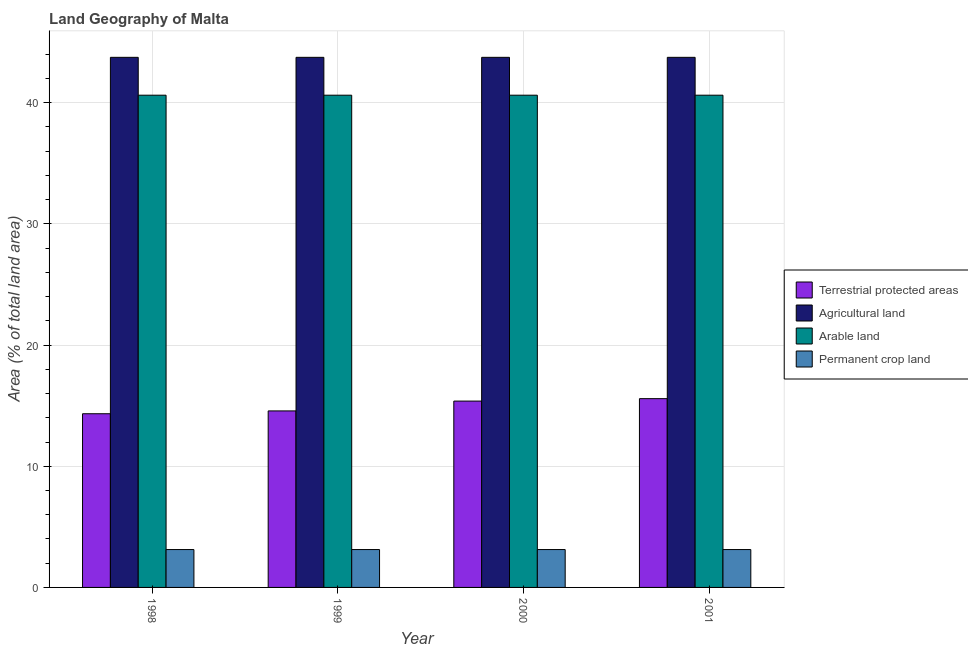How many different coloured bars are there?
Your response must be concise. 4. How many groups of bars are there?
Offer a very short reply. 4. In how many cases, is the number of bars for a given year not equal to the number of legend labels?
Offer a very short reply. 0. What is the percentage of land under terrestrial protection in 1999?
Make the answer very short. 14.57. Across all years, what is the maximum percentage of area under permanent crop land?
Your answer should be very brief. 3.12. Across all years, what is the minimum percentage of land under terrestrial protection?
Offer a terse response. 14.33. What is the total percentage of land under terrestrial protection in the graph?
Keep it short and to the point. 59.86. What is the difference between the percentage of area under permanent crop land in 2001 and the percentage of area under arable land in 2000?
Offer a terse response. 0. What is the average percentage of area under arable land per year?
Your answer should be very brief. 40.62. In the year 2001, what is the difference between the percentage of area under permanent crop land and percentage of land under terrestrial protection?
Ensure brevity in your answer.  0. In how many years, is the percentage of area under arable land greater than 18 %?
Offer a terse response. 4. What is the ratio of the percentage of area under agricultural land in 1998 to that in 1999?
Keep it short and to the point. 1. What does the 4th bar from the left in 2000 represents?
Offer a very short reply. Permanent crop land. What does the 3rd bar from the right in 1999 represents?
Give a very brief answer. Agricultural land. How many years are there in the graph?
Ensure brevity in your answer.  4. What is the difference between two consecutive major ticks on the Y-axis?
Ensure brevity in your answer.  10. Where does the legend appear in the graph?
Your answer should be compact. Center right. How many legend labels are there?
Offer a terse response. 4. What is the title of the graph?
Your answer should be compact. Land Geography of Malta. Does "France" appear as one of the legend labels in the graph?
Keep it short and to the point. No. What is the label or title of the Y-axis?
Offer a very short reply. Area (% of total land area). What is the Area (% of total land area) in Terrestrial protected areas in 1998?
Your answer should be very brief. 14.33. What is the Area (% of total land area) in Agricultural land in 1998?
Provide a succinct answer. 43.75. What is the Area (% of total land area) of Arable land in 1998?
Your answer should be compact. 40.62. What is the Area (% of total land area) of Permanent crop land in 1998?
Ensure brevity in your answer.  3.12. What is the Area (% of total land area) in Terrestrial protected areas in 1999?
Provide a succinct answer. 14.57. What is the Area (% of total land area) of Agricultural land in 1999?
Provide a succinct answer. 43.75. What is the Area (% of total land area) in Arable land in 1999?
Offer a terse response. 40.62. What is the Area (% of total land area) in Permanent crop land in 1999?
Offer a terse response. 3.12. What is the Area (% of total land area) in Terrestrial protected areas in 2000?
Offer a very short reply. 15.38. What is the Area (% of total land area) of Agricultural land in 2000?
Give a very brief answer. 43.75. What is the Area (% of total land area) in Arable land in 2000?
Offer a very short reply. 40.62. What is the Area (% of total land area) of Permanent crop land in 2000?
Make the answer very short. 3.12. What is the Area (% of total land area) in Terrestrial protected areas in 2001?
Offer a very short reply. 15.58. What is the Area (% of total land area) in Agricultural land in 2001?
Make the answer very short. 43.75. What is the Area (% of total land area) in Arable land in 2001?
Provide a succinct answer. 40.62. What is the Area (% of total land area) in Permanent crop land in 2001?
Keep it short and to the point. 3.12. Across all years, what is the maximum Area (% of total land area) of Terrestrial protected areas?
Your answer should be very brief. 15.58. Across all years, what is the maximum Area (% of total land area) in Agricultural land?
Give a very brief answer. 43.75. Across all years, what is the maximum Area (% of total land area) in Arable land?
Your answer should be very brief. 40.62. Across all years, what is the maximum Area (% of total land area) of Permanent crop land?
Keep it short and to the point. 3.12. Across all years, what is the minimum Area (% of total land area) in Terrestrial protected areas?
Make the answer very short. 14.33. Across all years, what is the minimum Area (% of total land area) of Agricultural land?
Provide a short and direct response. 43.75. Across all years, what is the minimum Area (% of total land area) of Arable land?
Offer a very short reply. 40.62. Across all years, what is the minimum Area (% of total land area) in Permanent crop land?
Your answer should be very brief. 3.12. What is the total Area (% of total land area) in Terrestrial protected areas in the graph?
Give a very brief answer. 59.86. What is the total Area (% of total land area) of Agricultural land in the graph?
Your answer should be compact. 175. What is the total Area (% of total land area) of Arable land in the graph?
Your response must be concise. 162.5. What is the difference between the Area (% of total land area) of Terrestrial protected areas in 1998 and that in 1999?
Your response must be concise. -0.23. What is the difference between the Area (% of total land area) in Permanent crop land in 1998 and that in 1999?
Give a very brief answer. 0. What is the difference between the Area (% of total land area) in Terrestrial protected areas in 1998 and that in 2000?
Your answer should be very brief. -1.04. What is the difference between the Area (% of total land area) in Agricultural land in 1998 and that in 2000?
Your answer should be compact. 0. What is the difference between the Area (% of total land area) of Arable land in 1998 and that in 2000?
Offer a very short reply. 0. What is the difference between the Area (% of total land area) in Terrestrial protected areas in 1998 and that in 2001?
Make the answer very short. -1.25. What is the difference between the Area (% of total land area) in Agricultural land in 1998 and that in 2001?
Offer a terse response. 0. What is the difference between the Area (% of total land area) of Arable land in 1998 and that in 2001?
Give a very brief answer. 0. What is the difference between the Area (% of total land area) of Terrestrial protected areas in 1999 and that in 2000?
Give a very brief answer. -0.81. What is the difference between the Area (% of total land area) of Arable land in 1999 and that in 2000?
Keep it short and to the point. 0. What is the difference between the Area (% of total land area) of Permanent crop land in 1999 and that in 2000?
Provide a succinct answer. 0. What is the difference between the Area (% of total land area) of Terrestrial protected areas in 1999 and that in 2001?
Offer a terse response. -1.01. What is the difference between the Area (% of total land area) of Arable land in 1999 and that in 2001?
Your response must be concise. 0. What is the difference between the Area (% of total land area) of Permanent crop land in 1999 and that in 2001?
Provide a short and direct response. 0. What is the difference between the Area (% of total land area) in Terrestrial protected areas in 2000 and that in 2001?
Your answer should be compact. -0.2. What is the difference between the Area (% of total land area) of Arable land in 2000 and that in 2001?
Give a very brief answer. 0. What is the difference between the Area (% of total land area) of Terrestrial protected areas in 1998 and the Area (% of total land area) of Agricultural land in 1999?
Keep it short and to the point. -29.42. What is the difference between the Area (% of total land area) of Terrestrial protected areas in 1998 and the Area (% of total land area) of Arable land in 1999?
Offer a terse response. -26.29. What is the difference between the Area (% of total land area) in Terrestrial protected areas in 1998 and the Area (% of total land area) in Permanent crop land in 1999?
Your answer should be compact. 11.21. What is the difference between the Area (% of total land area) in Agricultural land in 1998 and the Area (% of total land area) in Arable land in 1999?
Offer a terse response. 3.12. What is the difference between the Area (% of total land area) of Agricultural land in 1998 and the Area (% of total land area) of Permanent crop land in 1999?
Your answer should be compact. 40.62. What is the difference between the Area (% of total land area) in Arable land in 1998 and the Area (% of total land area) in Permanent crop land in 1999?
Offer a very short reply. 37.5. What is the difference between the Area (% of total land area) of Terrestrial protected areas in 1998 and the Area (% of total land area) of Agricultural land in 2000?
Your answer should be very brief. -29.42. What is the difference between the Area (% of total land area) in Terrestrial protected areas in 1998 and the Area (% of total land area) in Arable land in 2000?
Your response must be concise. -26.29. What is the difference between the Area (% of total land area) of Terrestrial protected areas in 1998 and the Area (% of total land area) of Permanent crop land in 2000?
Provide a succinct answer. 11.21. What is the difference between the Area (% of total land area) of Agricultural land in 1998 and the Area (% of total land area) of Arable land in 2000?
Provide a short and direct response. 3.12. What is the difference between the Area (% of total land area) in Agricultural land in 1998 and the Area (% of total land area) in Permanent crop land in 2000?
Offer a very short reply. 40.62. What is the difference between the Area (% of total land area) of Arable land in 1998 and the Area (% of total land area) of Permanent crop land in 2000?
Provide a short and direct response. 37.5. What is the difference between the Area (% of total land area) of Terrestrial protected areas in 1998 and the Area (% of total land area) of Agricultural land in 2001?
Make the answer very short. -29.42. What is the difference between the Area (% of total land area) of Terrestrial protected areas in 1998 and the Area (% of total land area) of Arable land in 2001?
Provide a succinct answer. -26.29. What is the difference between the Area (% of total land area) of Terrestrial protected areas in 1998 and the Area (% of total land area) of Permanent crop land in 2001?
Make the answer very short. 11.21. What is the difference between the Area (% of total land area) in Agricultural land in 1998 and the Area (% of total land area) in Arable land in 2001?
Provide a short and direct response. 3.12. What is the difference between the Area (% of total land area) in Agricultural land in 1998 and the Area (% of total land area) in Permanent crop land in 2001?
Give a very brief answer. 40.62. What is the difference between the Area (% of total land area) in Arable land in 1998 and the Area (% of total land area) in Permanent crop land in 2001?
Ensure brevity in your answer.  37.5. What is the difference between the Area (% of total land area) of Terrestrial protected areas in 1999 and the Area (% of total land area) of Agricultural land in 2000?
Ensure brevity in your answer.  -29.18. What is the difference between the Area (% of total land area) of Terrestrial protected areas in 1999 and the Area (% of total land area) of Arable land in 2000?
Your answer should be very brief. -26.06. What is the difference between the Area (% of total land area) in Terrestrial protected areas in 1999 and the Area (% of total land area) in Permanent crop land in 2000?
Provide a succinct answer. 11.44. What is the difference between the Area (% of total land area) in Agricultural land in 1999 and the Area (% of total land area) in Arable land in 2000?
Provide a succinct answer. 3.12. What is the difference between the Area (% of total land area) of Agricultural land in 1999 and the Area (% of total land area) of Permanent crop land in 2000?
Keep it short and to the point. 40.62. What is the difference between the Area (% of total land area) of Arable land in 1999 and the Area (% of total land area) of Permanent crop land in 2000?
Your response must be concise. 37.5. What is the difference between the Area (% of total land area) in Terrestrial protected areas in 1999 and the Area (% of total land area) in Agricultural land in 2001?
Your answer should be very brief. -29.18. What is the difference between the Area (% of total land area) of Terrestrial protected areas in 1999 and the Area (% of total land area) of Arable land in 2001?
Provide a short and direct response. -26.06. What is the difference between the Area (% of total land area) in Terrestrial protected areas in 1999 and the Area (% of total land area) in Permanent crop land in 2001?
Make the answer very short. 11.44. What is the difference between the Area (% of total land area) of Agricultural land in 1999 and the Area (% of total land area) of Arable land in 2001?
Your answer should be very brief. 3.12. What is the difference between the Area (% of total land area) of Agricultural land in 1999 and the Area (% of total land area) of Permanent crop land in 2001?
Your response must be concise. 40.62. What is the difference between the Area (% of total land area) in Arable land in 1999 and the Area (% of total land area) in Permanent crop land in 2001?
Make the answer very short. 37.5. What is the difference between the Area (% of total land area) in Terrestrial protected areas in 2000 and the Area (% of total land area) in Agricultural land in 2001?
Your response must be concise. -28.37. What is the difference between the Area (% of total land area) of Terrestrial protected areas in 2000 and the Area (% of total land area) of Arable land in 2001?
Offer a terse response. -25.25. What is the difference between the Area (% of total land area) of Terrestrial protected areas in 2000 and the Area (% of total land area) of Permanent crop land in 2001?
Give a very brief answer. 12.25. What is the difference between the Area (% of total land area) in Agricultural land in 2000 and the Area (% of total land area) in Arable land in 2001?
Offer a very short reply. 3.12. What is the difference between the Area (% of total land area) in Agricultural land in 2000 and the Area (% of total land area) in Permanent crop land in 2001?
Give a very brief answer. 40.62. What is the difference between the Area (% of total land area) of Arable land in 2000 and the Area (% of total land area) of Permanent crop land in 2001?
Give a very brief answer. 37.5. What is the average Area (% of total land area) in Terrestrial protected areas per year?
Give a very brief answer. 14.97. What is the average Area (% of total land area) in Agricultural land per year?
Your answer should be compact. 43.75. What is the average Area (% of total land area) in Arable land per year?
Your response must be concise. 40.62. What is the average Area (% of total land area) in Permanent crop land per year?
Offer a terse response. 3.12. In the year 1998, what is the difference between the Area (% of total land area) of Terrestrial protected areas and Area (% of total land area) of Agricultural land?
Make the answer very short. -29.42. In the year 1998, what is the difference between the Area (% of total land area) in Terrestrial protected areas and Area (% of total land area) in Arable land?
Give a very brief answer. -26.29. In the year 1998, what is the difference between the Area (% of total land area) of Terrestrial protected areas and Area (% of total land area) of Permanent crop land?
Ensure brevity in your answer.  11.21. In the year 1998, what is the difference between the Area (% of total land area) in Agricultural land and Area (% of total land area) in Arable land?
Make the answer very short. 3.12. In the year 1998, what is the difference between the Area (% of total land area) in Agricultural land and Area (% of total land area) in Permanent crop land?
Provide a short and direct response. 40.62. In the year 1998, what is the difference between the Area (% of total land area) of Arable land and Area (% of total land area) of Permanent crop land?
Ensure brevity in your answer.  37.5. In the year 1999, what is the difference between the Area (% of total land area) of Terrestrial protected areas and Area (% of total land area) of Agricultural land?
Provide a succinct answer. -29.18. In the year 1999, what is the difference between the Area (% of total land area) of Terrestrial protected areas and Area (% of total land area) of Arable land?
Provide a succinct answer. -26.06. In the year 1999, what is the difference between the Area (% of total land area) of Terrestrial protected areas and Area (% of total land area) of Permanent crop land?
Offer a terse response. 11.44. In the year 1999, what is the difference between the Area (% of total land area) of Agricultural land and Area (% of total land area) of Arable land?
Make the answer very short. 3.12. In the year 1999, what is the difference between the Area (% of total land area) of Agricultural land and Area (% of total land area) of Permanent crop land?
Provide a short and direct response. 40.62. In the year 1999, what is the difference between the Area (% of total land area) in Arable land and Area (% of total land area) in Permanent crop land?
Your answer should be very brief. 37.5. In the year 2000, what is the difference between the Area (% of total land area) in Terrestrial protected areas and Area (% of total land area) in Agricultural land?
Offer a very short reply. -28.37. In the year 2000, what is the difference between the Area (% of total land area) in Terrestrial protected areas and Area (% of total land area) in Arable land?
Your response must be concise. -25.25. In the year 2000, what is the difference between the Area (% of total land area) in Terrestrial protected areas and Area (% of total land area) in Permanent crop land?
Give a very brief answer. 12.25. In the year 2000, what is the difference between the Area (% of total land area) of Agricultural land and Area (% of total land area) of Arable land?
Offer a very short reply. 3.12. In the year 2000, what is the difference between the Area (% of total land area) of Agricultural land and Area (% of total land area) of Permanent crop land?
Keep it short and to the point. 40.62. In the year 2000, what is the difference between the Area (% of total land area) in Arable land and Area (% of total land area) in Permanent crop land?
Ensure brevity in your answer.  37.5. In the year 2001, what is the difference between the Area (% of total land area) in Terrestrial protected areas and Area (% of total land area) in Agricultural land?
Provide a succinct answer. -28.17. In the year 2001, what is the difference between the Area (% of total land area) of Terrestrial protected areas and Area (% of total land area) of Arable land?
Your response must be concise. -25.04. In the year 2001, what is the difference between the Area (% of total land area) in Terrestrial protected areas and Area (% of total land area) in Permanent crop land?
Provide a succinct answer. 12.46. In the year 2001, what is the difference between the Area (% of total land area) in Agricultural land and Area (% of total land area) in Arable land?
Offer a very short reply. 3.12. In the year 2001, what is the difference between the Area (% of total land area) of Agricultural land and Area (% of total land area) of Permanent crop land?
Provide a short and direct response. 40.62. In the year 2001, what is the difference between the Area (% of total land area) of Arable land and Area (% of total land area) of Permanent crop land?
Give a very brief answer. 37.5. What is the ratio of the Area (% of total land area) in Arable land in 1998 to that in 1999?
Your answer should be compact. 1. What is the ratio of the Area (% of total land area) in Permanent crop land in 1998 to that in 1999?
Your answer should be compact. 1. What is the ratio of the Area (% of total land area) of Terrestrial protected areas in 1998 to that in 2000?
Your answer should be compact. 0.93. What is the ratio of the Area (% of total land area) of Agricultural land in 1998 to that in 2000?
Offer a very short reply. 1. What is the ratio of the Area (% of total land area) in Permanent crop land in 1998 to that in 2000?
Keep it short and to the point. 1. What is the ratio of the Area (% of total land area) of Terrestrial protected areas in 1999 to that in 2000?
Make the answer very short. 0.95. What is the ratio of the Area (% of total land area) of Agricultural land in 1999 to that in 2000?
Your answer should be compact. 1. What is the ratio of the Area (% of total land area) of Arable land in 1999 to that in 2000?
Keep it short and to the point. 1. What is the ratio of the Area (% of total land area) of Permanent crop land in 1999 to that in 2000?
Give a very brief answer. 1. What is the ratio of the Area (% of total land area) of Terrestrial protected areas in 1999 to that in 2001?
Your response must be concise. 0.94. What is the ratio of the Area (% of total land area) in Agricultural land in 1999 to that in 2001?
Offer a terse response. 1. What is the ratio of the Area (% of total land area) in Arable land in 1999 to that in 2001?
Your answer should be compact. 1. What is the ratio of the Area (% of total land area) in Permanent crop land in 1999 to that in 2001?
Your answer should be very brief. 1. What is the ratio of the Area (% of total land area) in Terrestrial protected areas in 2000 to that in 2001?
Your response must be concise. 0.99. What is the ratio of the Area (% of total land area) of Agricultural land in 2000 to that in 2001?
Your answer should be compact. 1. What is the ratio of the Area (% of total land area) of Arable land in 2000 to that in 2001?
Provide a succinct answer. 1. What is the ratio of the Area (% of total land area) in Permanent crop land in 2000 to that in 2001?
Give a very brief answer. 1. What is the difference between the highest and the second highest Area (% of total land area) of Terrestrial protected areas?
Your answer should be very brief. 0.2. What is the difference between the highest and the second highest Area (% of total land area) in Agricultural land?
Offer a terse response. 0. What is the difference between the highest and the second highest Area (% of total land area) in Arable land?
Your answer should be very brief. 0. What is the difference between the highest and the lowest Area (% of total land area) in Terrestrial protected areas?
Offer a terse response. 1.25. What is the difference between the highest and the lowest Area (% of total land area) in Agricultural land?
Your answer should be compact. 0. 